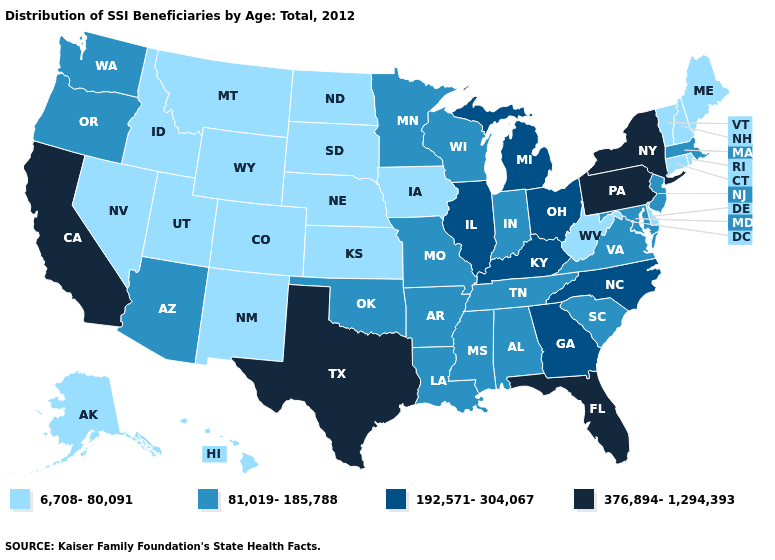Name the states that have a value in the range 192,571-304,067?
Keep it brief. Georgia, Illinois, Kentucky, Michigan, North Carolina, Ohio. Does Alabama have a lower value than California?
Write a very short answer. Yes. What is the value of Arizona?
Give a very brief answer. 81,019-185,788. What is the value of New Mexico?
Give a very brief answer. 6,708-80,091. How many symbols are there in the legend?
Keep it brief. 4. What is the highest value in the West ?
Give a very brief answer. 376,894-1,294,393. Name the states that have a value in the range 376,894-1,294,393?
Short answer required. California, Florida, New York, Pennsylvania, Texas. Among the states that border Utah , does Arizona have the highest value?
Give a very brief answer. Yes. Name the states that have a value in the range 6,708-80,091?
Answer briefly. Alaska, Colorado, Connecticut, Delaware, Hawaii, Idaho, Iowa, Kansas, Maine, Montana, Nebraska, Nevada, New Hampshire, New Mexico, North Dakota, Rhode Island, South Dakota, Utah, Vermont, West Virginia, Wyoming. Name the states that have a value in the range 192,571-304,067?
Concise answer only. Georgia, Illinois, Kentucky, Michigan, North Carolina, Ohio. What is the value of Texas?
Answer briefly. 376,894-1,294,393. Name the states that have a value in the range 192,571-304,067?
Quick response, please. Georgia, Illinois, Kentucky, Michigan, North Carolina, Ohio. What is the value of New Hampshire?
Concise answer only. 6,708-80,091. Which states have the lowest value in the Northeast?
Write a very short answer. Connecticut, Maine, New Hampshire, Rhode Island, Vermont. Is the legend a continuous bar?
Give a very brief answer. No. 